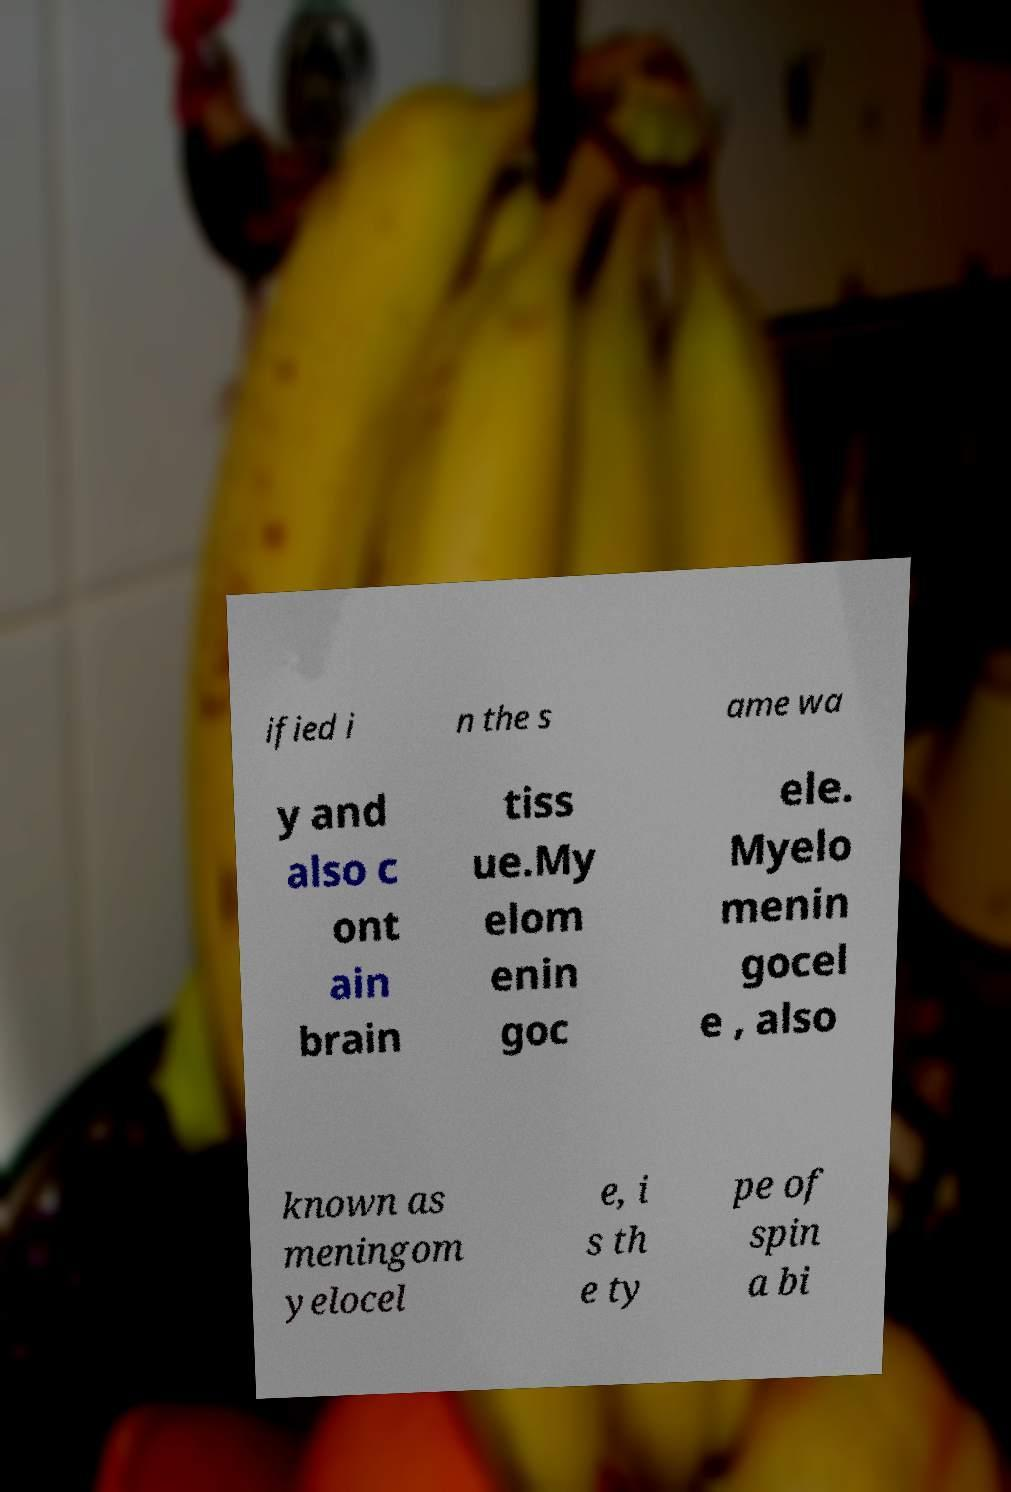What messages or text are displayed in this image? I need them in a readable, typed format. ified i n the s ame wa y and also c ont ain brain tiss ue.My elom enin goc ele. Myelo menin gocel e , also known as meningom yelocel e, i s th e ty pe of spin a bi 